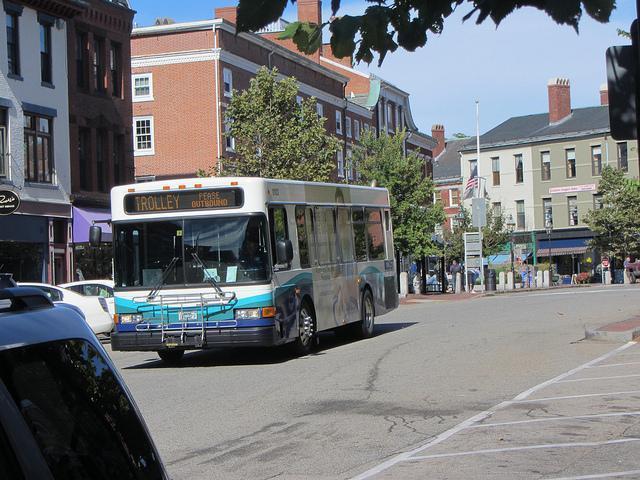How many cars are there?
Give a very brief answer. 2. How many clocks are in the shade?
Give a very brief answer. 0. 